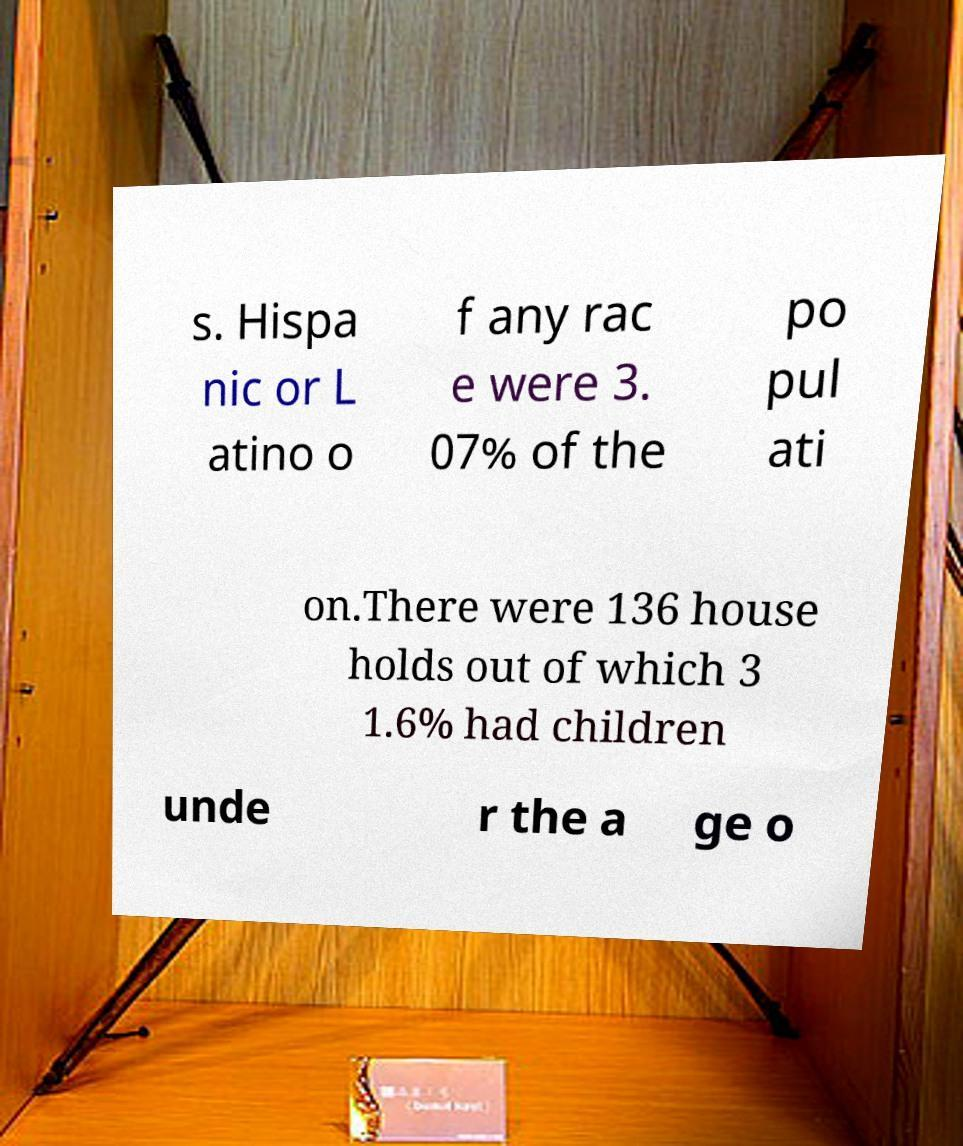Can you accurately transcribe the text from the provided image for me? s. Hispa nic or L atino o f any rac e were 3. 07% of the po pul ati on.There were 136 house holds out of which 3 1.6% had children unde r the a ge o 